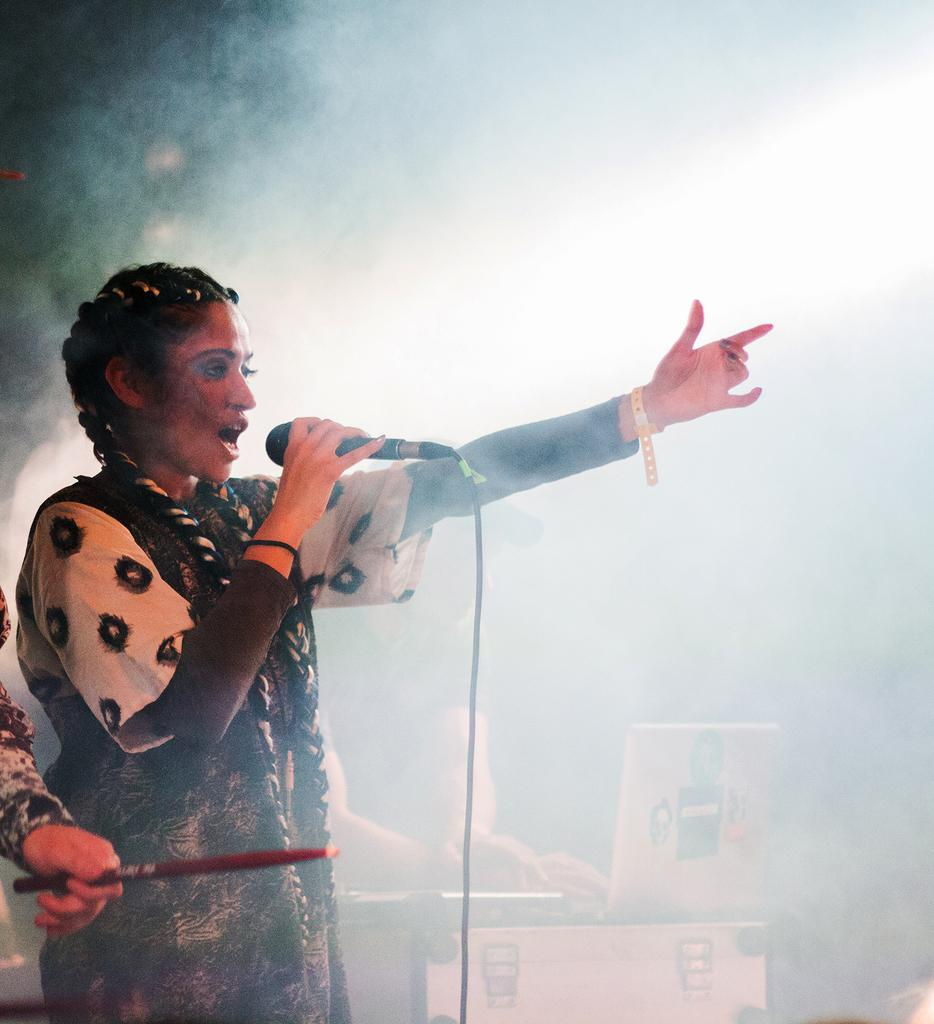What is the woman in the image doing? The woman is singing on a mic in the image. Who else is present in the image besides the woman? There are people in the image. What objects related to music can be seen in the image? There are musical instruments in the image. What other items are visible in the image? There are boxes in the image. What can be observed in the background of the image? There is a lot of smoke in the background of the image. What type of treatment is being administered to the woman in the image? There is no indication of any treatment being administered to the woman in the image; she is singing on a mic. Can you see a basket in the image? No, there is no basket present in the image. 